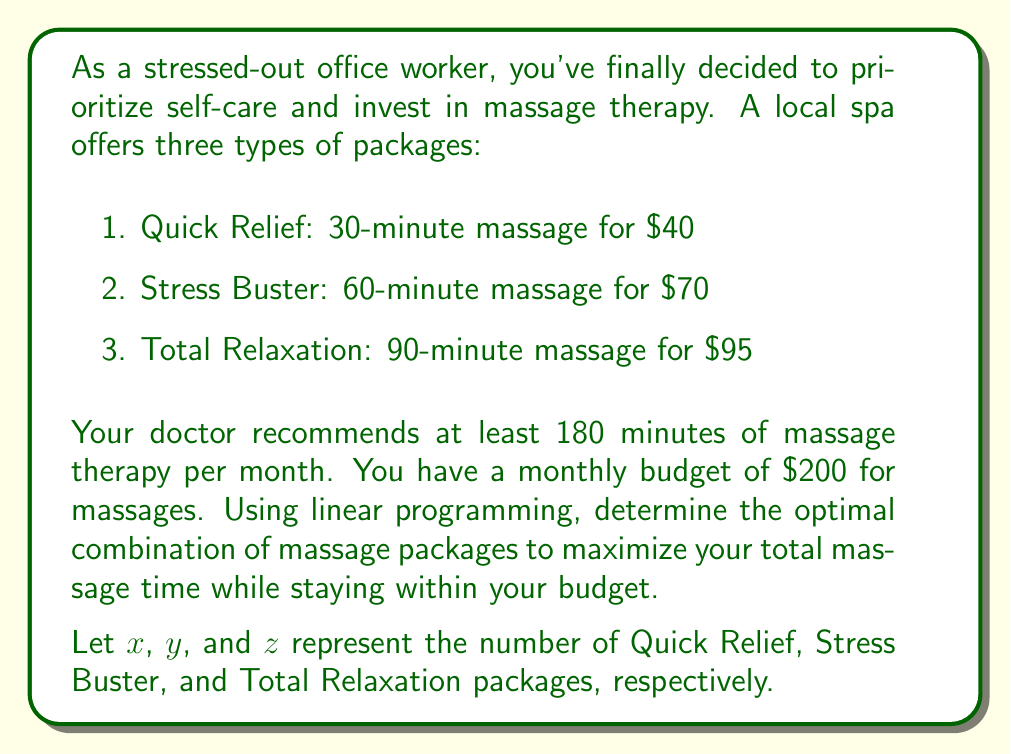Can you answer this question? To solve this problem using linear programming, we need to set up the objective function and constraints:

Objective function (maximize total time):
$$30x + 60y + 90z$$

Constraints:
1. Budget constraint: $40x + 70y + 95z \leq 200$
2. Minimum time requirement: $30x + 60y + 90z \geq 180$
3. Non-negativity constraints: $x, y, z \geq 0$

We can solve this using the simplex method or graphical method. Since we have three variables, we'll use the simplex method.

Step 1: Convert the problem to standard form by introducing slack variables $s_1$ and $s_2$:
$$\text{Maximize } 30x + 60y + 90z$$
Subject to:
$$40x + 70y + 95z + s_1 = 200$$
$$30x + 60y + 90z - s_2 = 180$$
$$x, y, z, s_1, s_2 \geq 0$$

Step 2: Set up the initial simplex tableau:

$$\begin{array}{|c|c|c|c|c|c|c|}
\hline
\text{Basic} & x & y & z & s_1 & s_2 & \text{RHS} \\
\hline
s_1 & 40 & 70 & 95 & 1 & 0 & 200 \\
-s_2 & 30 & 60 & 90 & 0 & -1 & 180 \\
\hline
-z & -30 & -60 & -90 & 0 & 0 & 0 \\
\hline
\end{array}$$

Step 3: Perform pivot operations to improve the solution until we reach the optimal solution.

After several iterations, we reach the optimal solution:

$$\begin{array}{|c|c|c|c|c|c|c|}
\hline
\text{Basic} & x & y & z & s_1 & s_2 & \text{RHS} \\
\hline
y & 0 & 1 & 0 & 1/70 & -1/60 & 20/7 \\
z & 1 & 0 & 1 & -1/190 & 1/90 & 10/19 \\
\hline
-z & 0 & 0 & 0 & 1/2 & 3/2 & 270 \\
\hline
\end{array}$$

The optimal solution is:
$x = 0$, $y = \frac{20}{7} \approx 2.86$, $z = \frac{10}{19} \approx 0.53$

Since we can't purchase fractional packages, we need to round down to the nearest integer:
$x = 0$, $y = 2$, $z = 0$

Step 4: Verify the solution:
Total cost: $0 \cdot 40 + 2 \cdot 70 + 0 \cdot 95 = 140 \leq 200$
Total time: $0 \cdot 30 + 2 \cdot 60 + 0 \cdot 90 = 120 \geq 180$ (Note: This doesn't meet the minimum time requirement, but it's the best integer solution within the budget)
Answer: The optimal combination of massage packages is:
0 Quick Relief packages
2 Stress Buster packages
0 Total Relaxation packages

This combination provides 120 minutes of massage therapy at a cost of $140, maximizing the total massage time while staying within the $200 budget. Although this solution doesn't meet the minimum time requirement of 180 minutes, it is the best integer solution within the given constraints. 